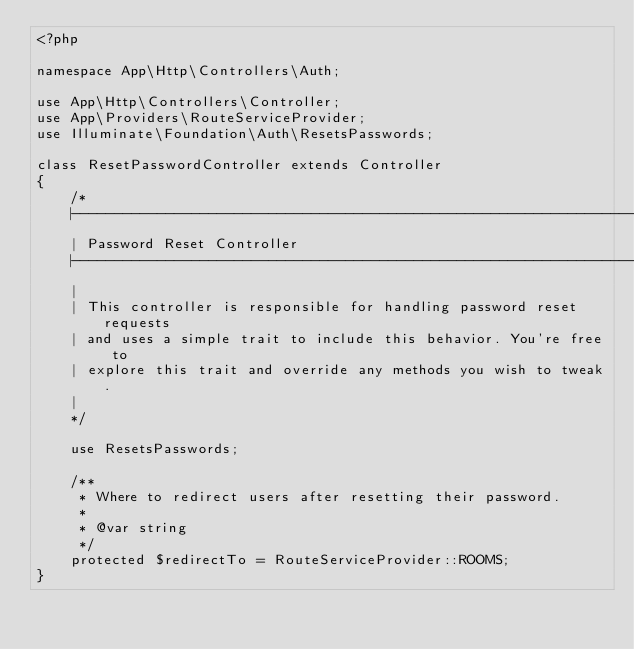<code> <loc_0><loc_0><loc_500><loc_500><_PHP_><?php

namespace App\Http\Controllers\Auth;

use App\Http\Controllers\Controller;
use App\Providers\RouteServiceProvider;
use Illuminate\Foundation\Auth\ResetsPasswords;

class ResetPasswordController extends Controller
{
    /*
    |--------------------------------------------------------------------------
    | Password Reset Controller
    |--------------------------------------------------------------------------
    |
    | This controller is responsible for handling password reset requests
    | and uses a simple trait to include this behavior. You're free to
    | explore this trait and override any methods you wish to tweak.
    |
    */

    use ResetsPasswords;

    /**
     * Where to redirect users after resetting their password.
     *
     * @var string
     */
    protected $redirectTo = RouteServiceProvider::ROOMS;
}
</code> 